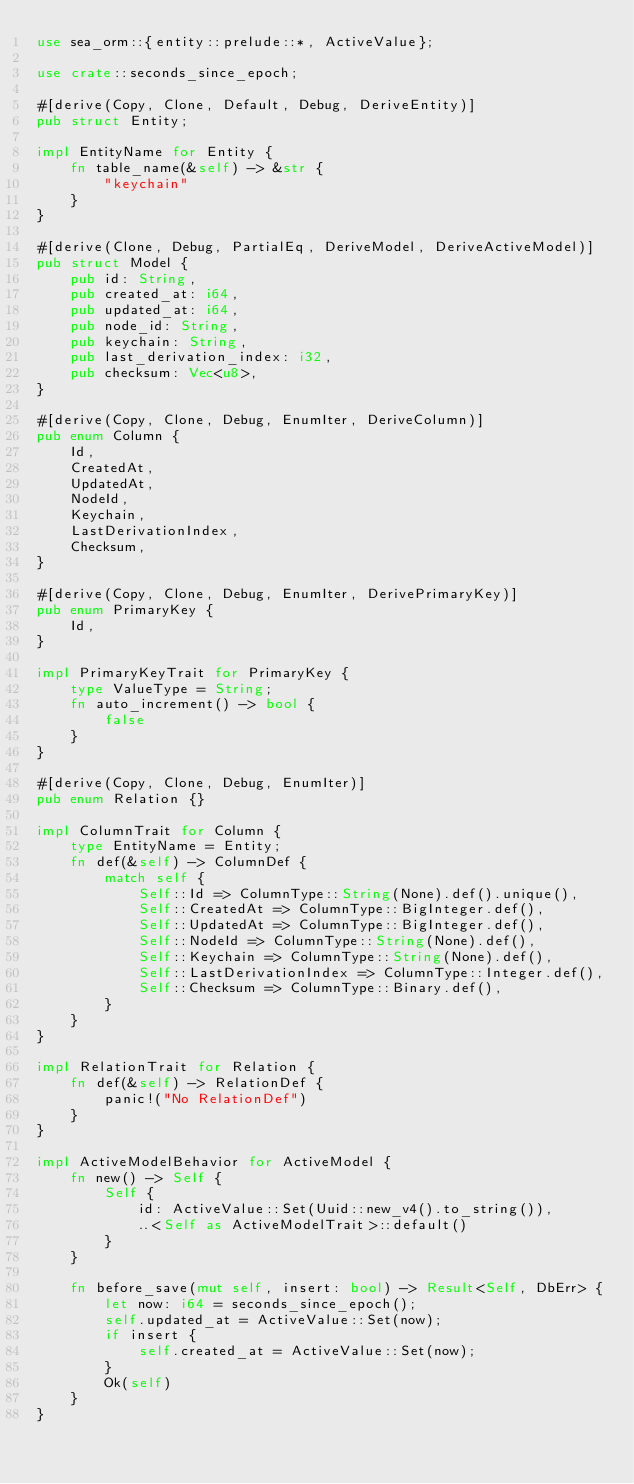Convert code to text. <code><loc_0><loc_0><loc_500><loc_500><_Rust_>use sea_orm::{entity::prelude::*, ActiveValue};

use crate::seconds_since_epoch;

#[derive(Copy, Clone, Default, Debug, DeriveEntity)]
pub struct Entity;

impl EntityName for Entity {
    fn table_name(&self) -> &str {
        "keychain"
    }
}

#[derive(Clone, Debug, PartialEq, DeriveModel, DeriveActiveModel)]
pub struct Model {
    pub id: String,
    pub created_at: i64,
    pub updated_at: i64,
    pub node_id: String,
    pub keychain: String,
    pub last_derivation_index: i32,
    pub checksum: Vec<u8>,
}

#[derive(Copy, Clone, Debug, EnumIter, DeriveColumn)]
pub enum Column {
    Id,
    CreatedAt,
    UpdatedAt,
    NodeId,
    Keychain,
    LastDerivationIndex,
    Checksum,
}

#[derive(Copy, Clone, Debug, EnumIter, DerivePrimaryKey)]
pub enum PrimaryKey {
    Id,
}

impl PrimaryKeyTrait for PrimaryKey {
    type ValueType = String;
    fn auto_increment() -> bool {
        false
    }
}

#[derive(Copy, Clone, Debug, EnumIter)]
pub enum Relation {}

impl ColumnTrait for Column {
    type EntityName = Entity;
    fn def(&self) -> ColumnDef {
        match self {
            Self::Id => ColumnType::String(None).def().unique(),
            Self::CreatedAt => ColumnType::BigInteger.def(),
            Self::UpdatedAt => ColumnType::BigInteger.def(),
            Self::NodeId => ColumnType::String(None).def(),
            Self::Keychain => ColumnType::String(None).def(),
            Self::LastDerivationIndex => ColumnType::Integer.def(),
            Self::Checksum => ColumnType::Binary.def(),
        }
    }
}

impl RelationTrait for Relation {
    fn def(&self) -> RelationDef {
        panic!("No RelationDef")
    }
}

impl ActiveModelBehavior for ActiveModel {
    fn new() -> Self {
        Self {
            id: ActiveValue::Set(Uuid::new_v4().to_string()),
            ..<Self as ActiveModelTrait>::default()
        }
    }

    fn before_save(mut self, insert: bool) -> Result<Self, DbErr> {
        let now: i64 = seconds_since_epoch();
        self.updated_at = ActiveValue::Set(now);
        if insert {
            self.created_at = ActiveValue::Set(now);
        }
        Ok(self)
    }
}
</code> 